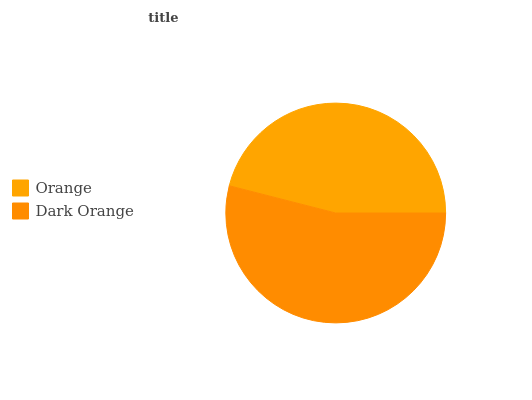Is Orange the minimum?
Answer yes or no. Yes. Is Dark Orange the maximum?
Answer yes or no. Yes. Is Dark Orange the minimum?
Answer yes or no. No. Is Dark Orange greater than Orange?
Answer yes or no. Yes. Is Orange less than Dark Orange?
Answer yes or no. Yes. Is Orange greater than Dark Orange?
Answer yes or no. No. Is Dark Orange less than Orange?
Answer yes or no. No. Is Dark Orange the high median?
Answer yes or no. Yes. Is Orange the low median?
Answer yes or no. Yes. Is Orange the high median?
Answer yes or no. No. Is Dark Orange the low median?
Answer yes or no. No. 